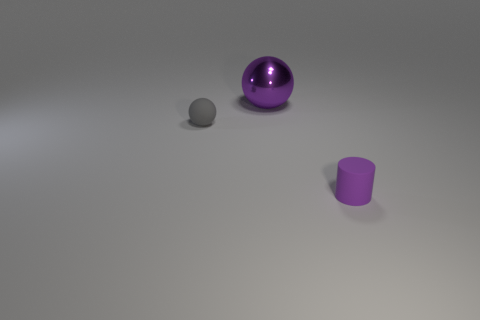Add 3 tiny cyan metallic balls. How many objects exist? 6 Subtract all cylinders. How many objects are left? 2 Subtract all gray matte balls. Subtract all small gray objects. How many objects are left? 1 Add 3 small objects. How many small objects are left? 5 Add 3 small purple cylinders. How many small purple cylinders exist? 4 Subtract 0 green spheres. How many objects are left? 3 